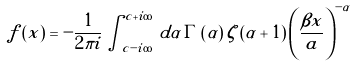Convert formula to latex. <formula><loc_0><loc_0><loc_500><loc_500>f \left ( x \right ) = - \frac { 1 } { 2 \pi i } \int _ { c - i \infty } ^ { c + i \infty } \, d \alpha \, \Gamma \left ( \alpha \right ) \zeta \left ( \alpha + 1 \right ) \left ( \frac { \beta x } { a } \right ) ^ { - \alpha }</formula> 